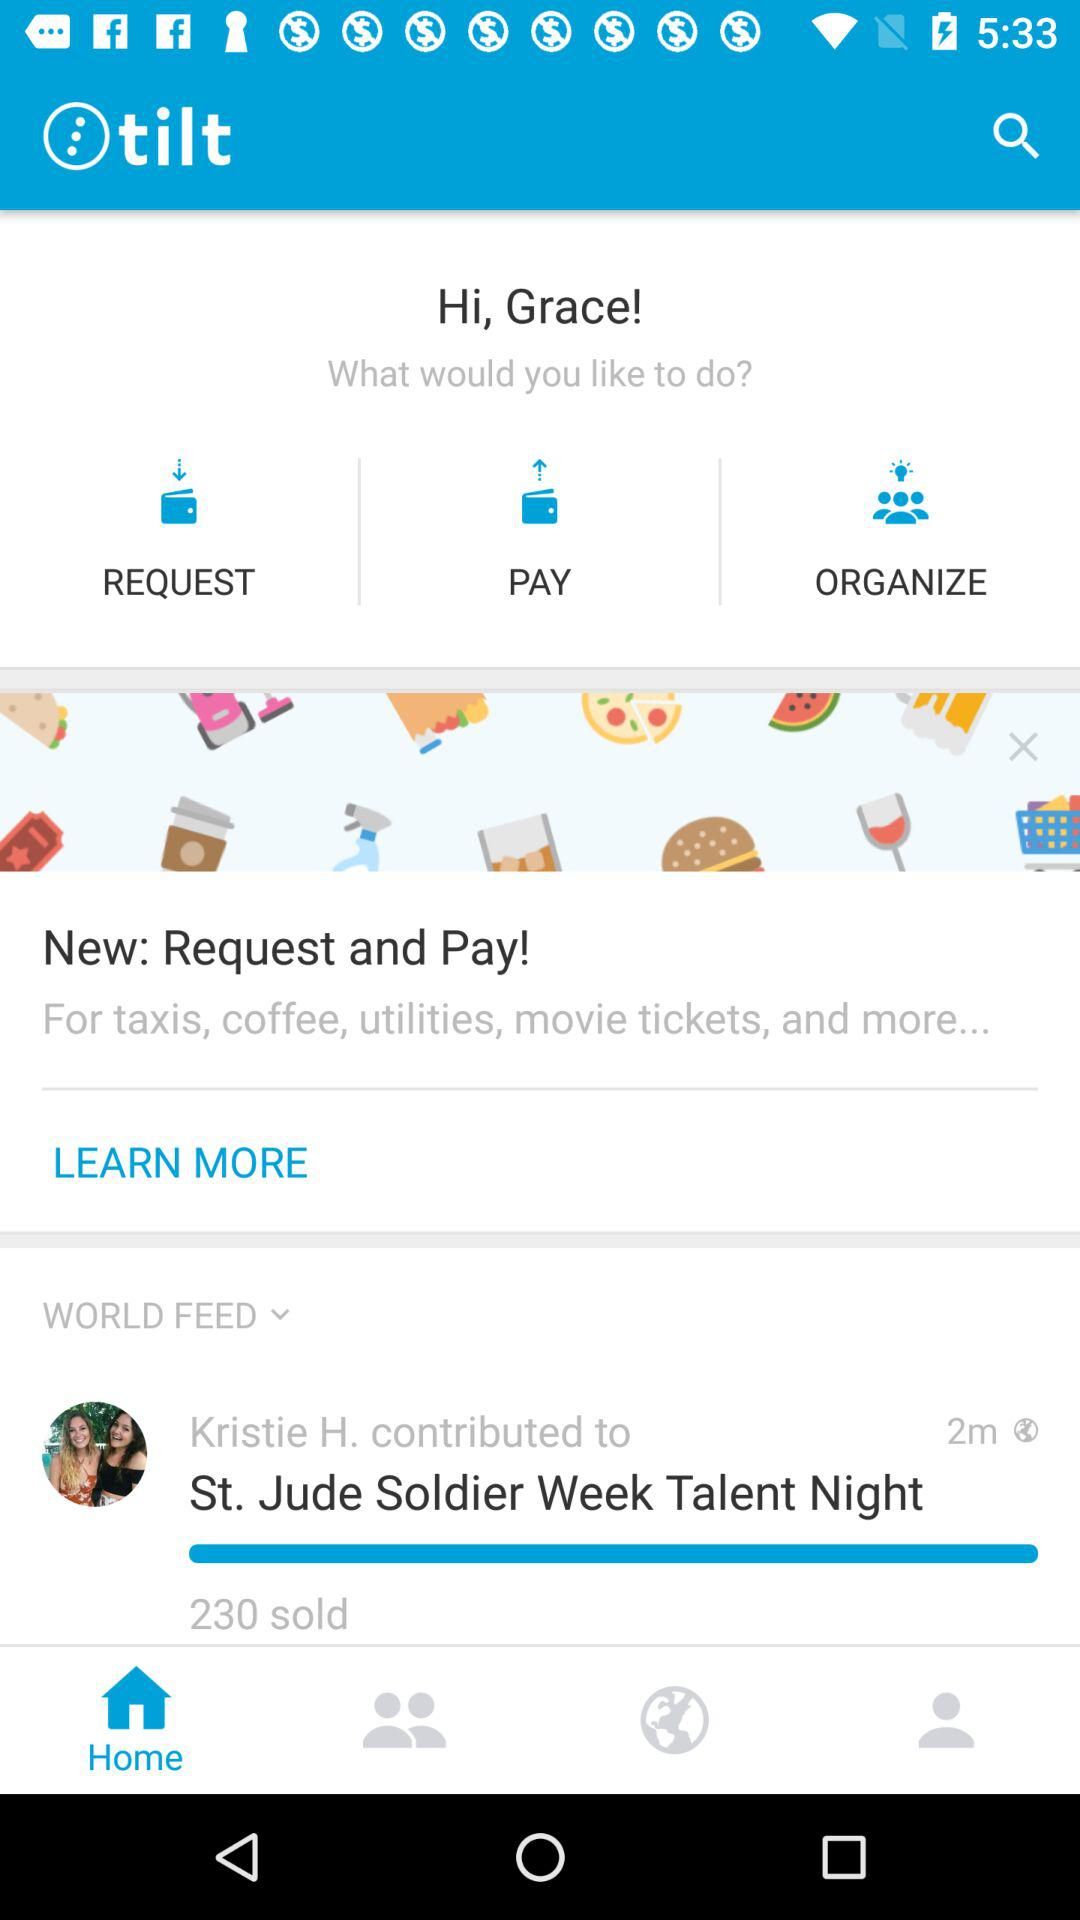How many people are in the photo at the bottom of the screen?
Answer the question using a single word or phrase. 2 